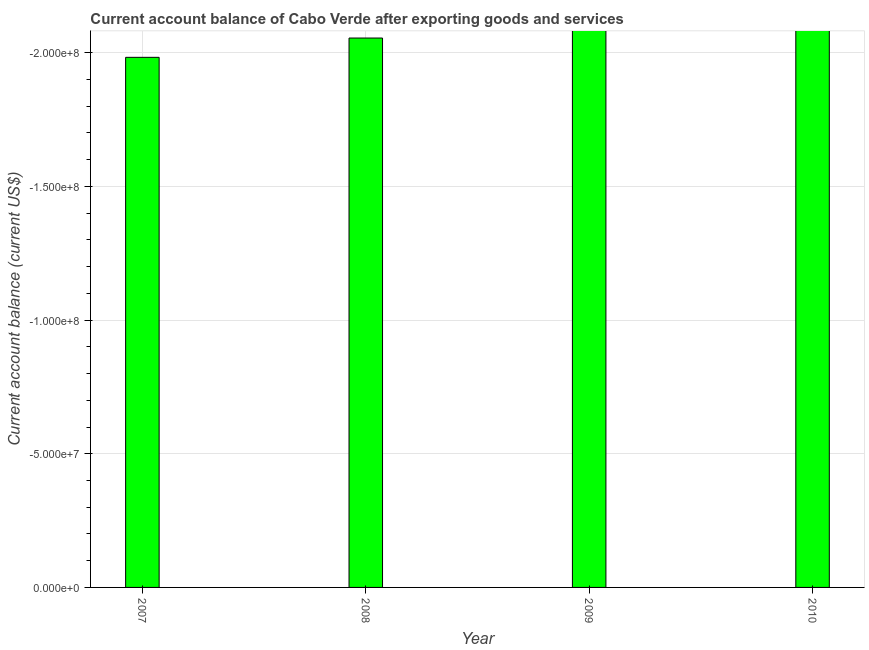Does the graph contain any zero values?
Give a very brief answer. Yes. Does the graph contain grids?
Offer a very short reply. Yes. What is the title of the graph?
Your answer should be very brief. Current account balance of Cabo Verde after exporting goods and services. What is the label or title of the Y-axis?
Your response must be concise. Current account balance (current US$). What is the current account balance in 2010?
Keep it short and to the point. 0. Across all years, what is the minimum current account balance?
Ensure brevity in your answer.  0. What is the average current account balance per year?
Your answer should be compact. 0. In how many years, is the current account balance greater than -40000000 US$?
Keep it short and to the point. 0. In how many years, is the current account balance greater than the average current account balance taken over all years?
Make the answer very short. 0. Are all the bars in the graph horizontal?
Your answer should be very brief. No. How many years are there in the graph?
Your answer should be compact. 4. What is the difference between two consecutive major ticks on the Y-axis?
Offer a terse response. 5.00e+07. Are the values on the major ticks of Y-axis written in scientific E-notation?
Your answer should be compact. Yes. What is the Current account balance (current US$) in 2010?
Offer a terse response. 0. 